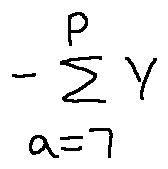<formula> <loc_0><loc_0><loc_500><loc_500>- \sum \lim i t s _ { a = 7 } ^ { P } Y</formula> 